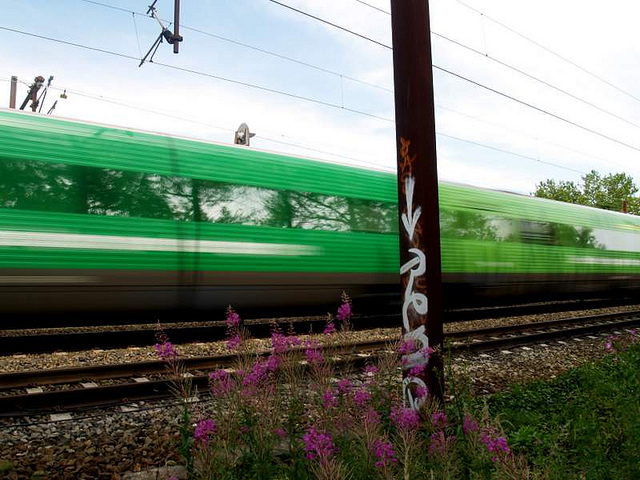Read and extract the text from this image. Reno Reno 